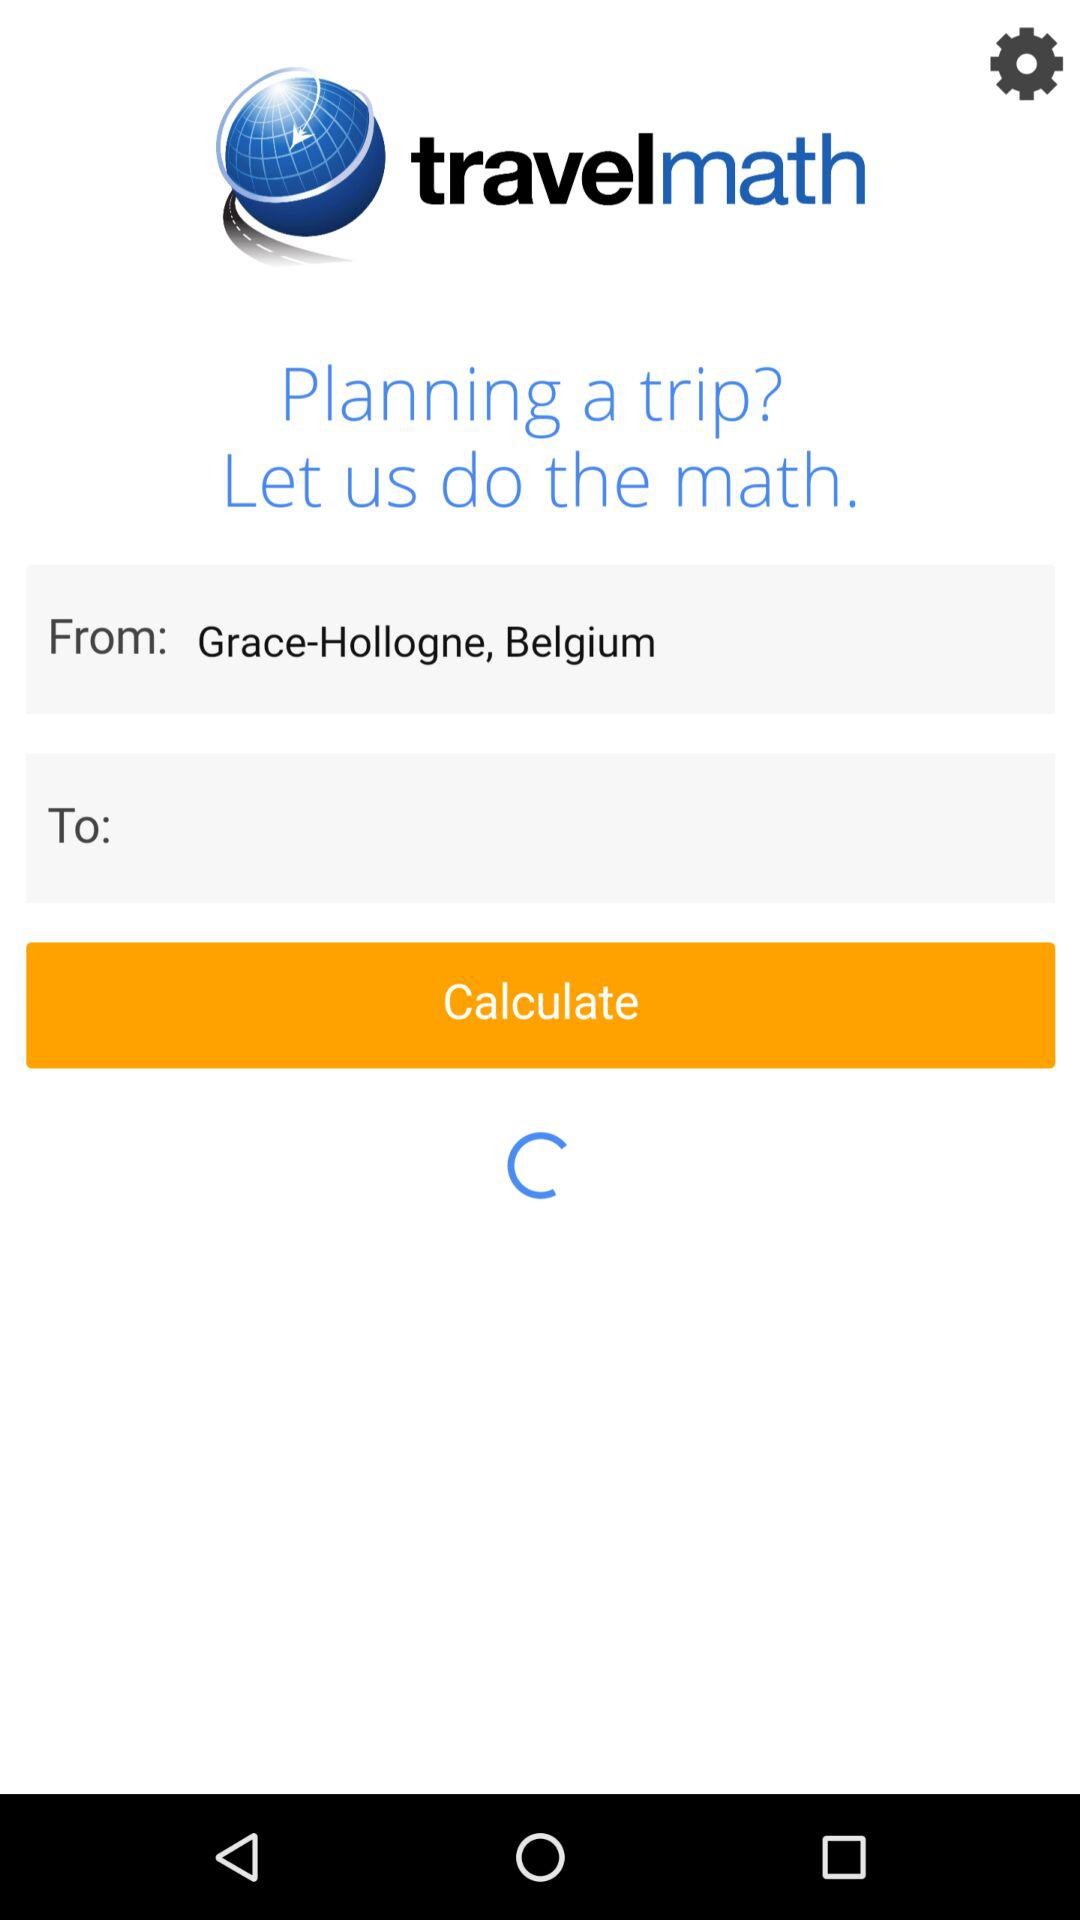What is the starting location of the trip? The starting location is Grace-Hollogne, Belgium. 